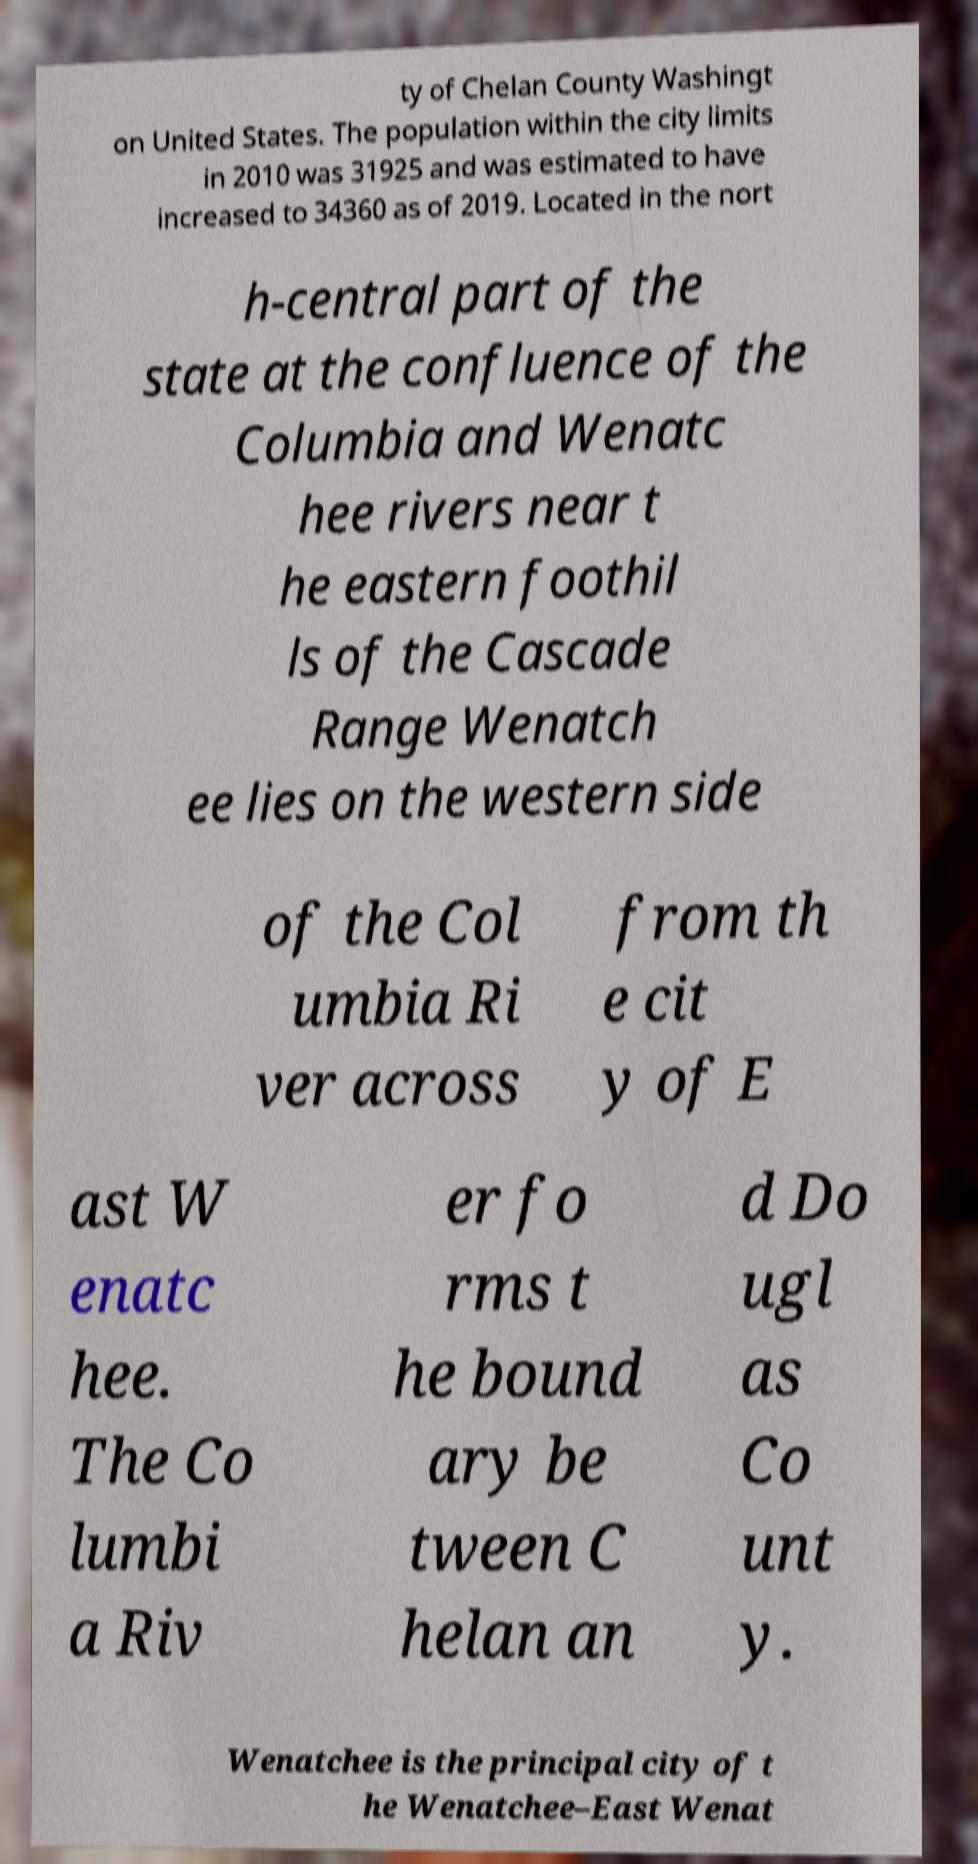There's text embedded in this image that I need extracted. Can you transcribe it verbatim? ty of Chelan County Washingt on United States. The population within the city limits in 2010 was 31925 and was estimated to have increased to 34360 as of 2019. Located in the nort h-central part of the state at the confluence of the Columbia and Wenatc hee rivers near t he eastern foothil ls of the Cascade Range Wenatch ee lies on the western side of the Col umbia Ri ver across from th e cit y of E ast W enatc hee. The Co lumbi a Riv er fo rms t he bound ary be tween C helan an d Do ugl as Co unt y. Wenatchee is the principal city of t he Wenatchee–East Wenat 